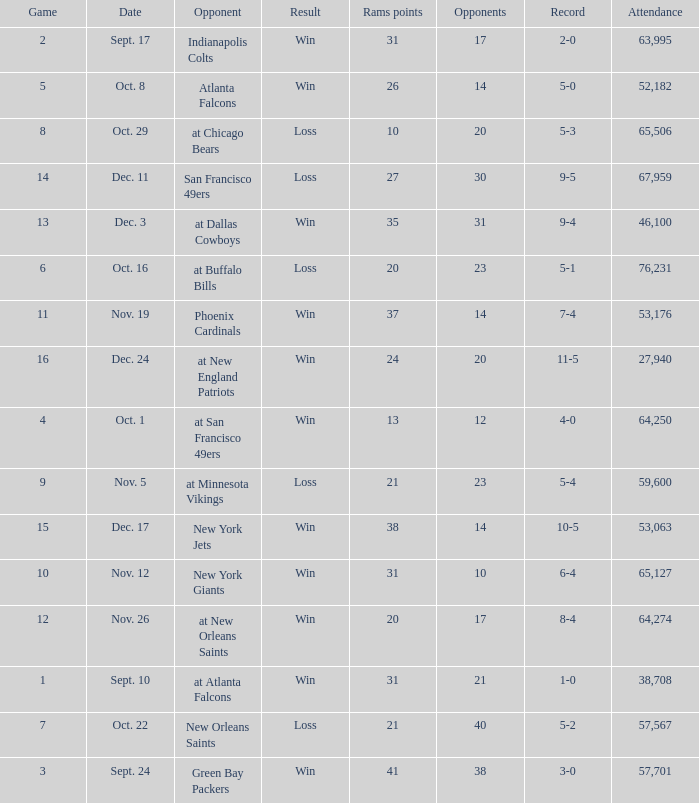What was the attendance where the record was 8-4? 64274.0. 